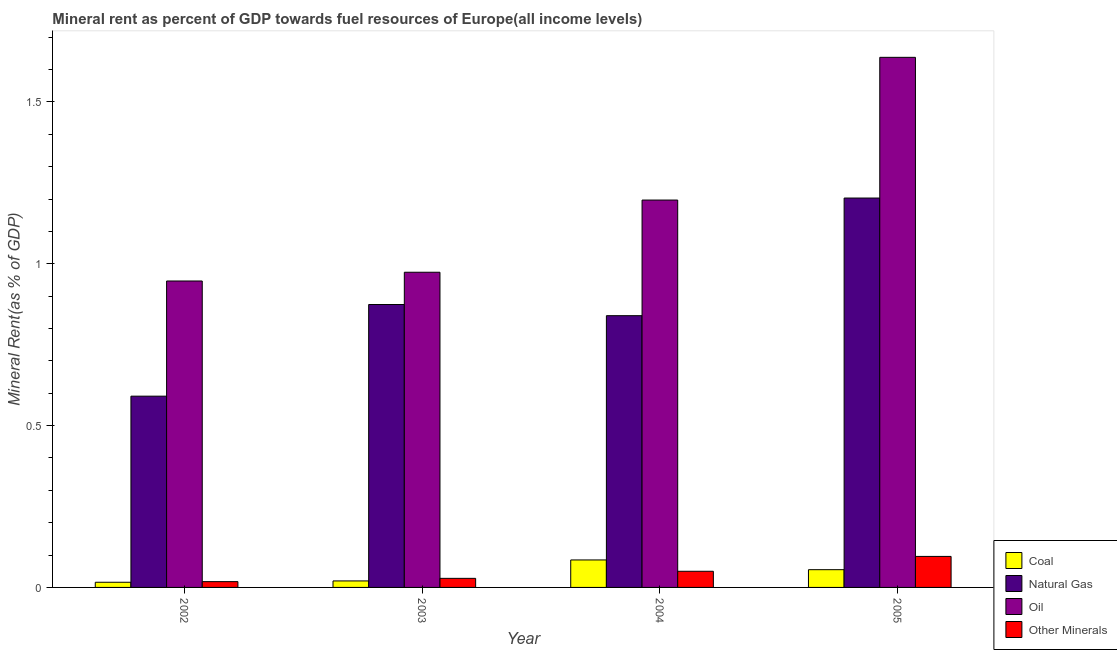How many different coloured bars are there?
Keep it short and to the point. 4. What is the label of the 2nd group of bars from the left?
Make the answer very short. 2003. In how many cases, is the number of bars for a given year not equal to the number of legend labels?
Provide a succinct answer. 0. What is the coal rent in 2003?
Your response must be concise. 0.02. Across all years, what is the maximum oil rent?
Keep it short and to the point. 1.64. Across all years, what is the minimum oil rent?
Provide a short and direct response. 0.95. What is the total coal rent in the graph?
Your answer should be compact. 0.18. What is the difference between the coal rent in 2003 and that in 2005?
Provide a short and direct response. -0.03. What is the difference between the oil rent in 2003 and the coal rent in 2002?
Your answer should be very brief. 0.03. What is the average  rent of other minerals per year?
Keep it short and to the point. 0.05. In the year 2004, what is the difference between the coal rent and oil rent?
Ensure brevity in your answer.  0. What is the ratio of the natural gas rent in 2003 to that in 2005?
Offer a very short reply. 0.73. Is the coal rent in 2004 less than that in 2005?
Your answer should be compact. No. What is the difference between the highest and the second highest natural gas rent?
Give a very brief answer. 0.33. What is the difference between the highest and the lowest oil rent?
Provide a succinct answer. 0.69. Is the sum of the coal rent in 2003 and 2004 greater than the maximum oil rent across all years?
Your answer should be very brief. Yes. Is it the case that in every year, the sum of the  rent of other minerals and coal rent is greater than the sum of natural gas rent and oil rent?
Keep it short and to the point. No. What does the 3rd bar from the left in 2002 represents?
Provide a succinct answer. Oil. What does the 4th bar from the right in 2004 represents?
Provide a short and direct response. Coal. How many bars are there?
Offer a terse response. 16. Does the graph contain any zero values?
Ensure brevity in your answer.  No. Where does the legend appear in the graph?
Offer a terse response. Bottom right. How many legend labels are there?
Your answer should be compact. 4. How are the legend labels stacked?
Ensure brevity in your answer.  Vertical. What is the title of the graph?
Offer a very short reply. Mineral rent as percent of GDP towards fuel resources of Europe(all income levels). What is the label or title of the Y-axis?
Your answer should be compact. Mineral Rent(as % of GDP). What is the Mineral Rent(as % of GDP) in Coal in 2002?
Your answer should be very brief. 0.02. What is the Mineral Rent(as % of GDP) in Natural Gas in 2002?
Make the answer very short. 0.59. What is the Mineral Rent(as % of GDP) in Oil in 2002?
Give a very brief answer. 0.95. What is the Mineral Rent(as % of GDP) in Other Minerals in 2002?
Ensure brevity in your answer.  0.02. What is the Mineral Rent(as % of GDP) of Coal in 2003?
Your response must be concise. 0.02. What is the Mineral Rent(as % of GDP) in Natural Gas in 2003?
Keep it short and to the point. 0.87. What is the Mineral Rent(as % of GDP) in Oil in 2003?
Offer a terse response. 0.97. What is the Mineral Rent(as % of GDP) of Other Minerals in 2003?
Your answer should be very brief. 0.03. What is the Mineral Rent(as % of GDP) in Coal in 2004?
Ensure brevity in your answer.  0.08. What is the Mineral Rent(as % of GDP) of Natural Gas in 2004?
Provide a succinct answer. 0.84. What is the Mineral Rent(as % of GDP) in Oil in 2004?
Ensure brevity in your answer.  1.2. What is the Mineral Rent(as % of GDP) of Other Minerals in 2004?
Offer a terse response. 0.05. What is the Mineral Rent(as % of GDP) of Coal in 2005?
Ensure brevity in your answer.  0.05. What is the Mineral Rent(as % of GDP) of Natural Gas in 2005?
Give a very brief answer. 1.2. What is the Mineral Rent(as % of GDP) of Oil in 2005?
Your answer should be compact. 1.64. What is the Mineral Rent(as % of GDP) of Other Minerals in 2005?
Your answer should be very brief. 0.1. Across all years, what is the maximum Mineral Rent(as % of GDP) of Coal?
Make the answer very short. 0.08. Across all years, what is the maximum Mineral Rent(as % of GDP) in Natural Gas?
Provide a short and direct response. 1.2. Across all years, what is the maximum Mineral Rent(as % of GDP) of Oil?
Ensure brevity in your answer.  1.64. Across all years, what is the maximum Mineral Rent(as % of GDP) of Other Minerals?
Your response must be concise. 0.1. Across all years, what is the minimum Mineral Rent(as % of GDP) of Coal?
Ensure brevity in your answer.  0.02. Across all years, what is the minimum Mineral Rent(as % of GDP) in Natural Gas?
Ensure brevity in your answer.  0.59. Across all years, what is the minimum Mineral Rent(as % of GDP) in Oil?
Your answer should be compact. 0.95. Across all years, what is the minimum Mineral Rent(as % of GDP) of Other Minerals?
Make the answer very short. 0.02. What is the total Mineral Rent(as % of GDP) in Coal in the graph?
Your response must be concise. 0.18. What is the total Mineral Rent(as % of GDP) in Natural Gas in the graph?
Provide a short and direct response. 3.51. What is the total Mineral Rent(as % of GDP) of Oil in the graph?
Offer a terse response. 4.76. What is the total Mineral Rent(as % of GDP) of Other Minerals in the graph?
Give a very brief answer. 0.19. What is the difference between the Mineral Rent(as % of GDP) of Coal in 2002 and that in 2003?
Give a very brief answer. -0. What is the difference between the Mineral Rent(as % of GDP) of Natural Gas in 2002 and that in 2003?
Your response must be concise. -0.28. What is the difference between the Mineral Rent(as % of GDP) of Oil in 2002 and that in 2003?
Ensure brevity in your answer.  -0.03. What is the difference between the Mineral Rent(as % of GDP) in Other Minerals in 2002 and that in 2003?
Make the answer very short. -0.01. What is the difference between the Mineral Rent(as % of GDP) in Coal in 2002 and that in 2004?
Offer a terse response. -0.07. What is the difference between the Mineral Rent(as % of GDP) of Natural Gas in 2002 and that in 2004?
Offer a terse response. -0.25. What is the difference between the Mineral Rent(as % of GDP) in Oil in 2002 and that in 2004?
Offer a very short reply. -0.25. What is the difference between the Mineral Rent(as % of GDP) in Other Minerals in 2002 and that in 2004?
Offer a very short reply. -0.03. What is the difference between the Mineral Rent(as % of GDP) of Coal in 2002 and that in 2005?
Your answer should be very brief. -0.04. What is the difference between the Mineral Rent(as % of GDP) in Natural Gas in 2002 and that in 2005?
Provide a short and direct response. -0.61. What is the difference between the Mineral Rent(as % of GDP) of Oil in 2002 and that in 2005?
Keep it short and to the point. -0.69. What is the difference between the Mineral Rent(as % of GDP) of Other Minerals in 2002 and that in 2005?
Make the answer very short. -0.08. What is the difference between the Mineral Rent(as % of GDP) of Coal in 2003 and that in 2004?
Keep it short and to the point. -0.06. What is the difference between the Mineral Rent(as % of GDP) in Natural Gas in 2003 and that in 2004?
Offer a terse response. 0.03. What is the difference between the Mineral Rent(as % of GDP) in Oil in 2003 and that in 2004?
Your answer should be compact. -0.22. What is the difference between the Mineral Rent(as % of GDP) of Other Minerals in 2003 and that in 2004?
Ensure brevity in your answer.  -0.02. What is the difference between the Mineral Rent(as % of GDP) in Coal in 2003 and that in 2005?
Offer a terse response. -0.03. What is the difference between the Mineral Rent(as % of GDP) of Natural Gas in 2003 and that in 2005?
Your response must be concise. -0.33. What is the difference between the Mineral Rent(as % of GDP) in Oil in 2003 and that in 2005?
Keep it short and to the point. -0.66. What is the difference between the Mineral Rent(as % of GDP) in Other Minerals in 2003 and that in 2005?
Offer a terse response. -0.07. What is the difference between the Mineral Rent(as % of GDP) of Coal in 2004 and that in 2005?
Keep it short and to the point. 0.03. What is the difference between the Mineral Rent(as % of GDP) in Natural Gas in 2004 and that in 2005?
Make the answer very short. -0.36. What is the difference between the Mineral Rent(as % of GDP) in Oil in 2004 and that in 2005?
Offer a terse response. -0.44. What is the difference between the Mineral Rent(as % of GDP) of Other Minerals in 2004 and that in 2005?
Provide a short and direct response. -0.05. What is the difference between the Mineral Rent(as % of GDP) of Coal in 2002 and the Mineral Rent(as % of GDP) of Natural Gas in 2003?
Give a very brief answer. -0.86. What is the difference between the Mineral Rent(as % of GDP) in Coal in 2002 and the Mineral Rent(as % of GDP) in Oil in 2003?
Ensure brevity in your answer.  -0.96. What is the difference between the Mineral Rent(as % of GDP) in Coal in 2002 and the Mineral Rent(as % of GDP) in Other Minerals in 2003?
Provide a succinct answer. -0.01. What is the difference between the Mineral Rent(as % of GDP) in Natural Gas in 2002 and the Mineral Rent(as % of GDP) in Oil in 2003?
Your answer should be very brief. -0.38. What is the difference between the Mineral Rent(as % of GDP) of Natural Gas in 2002 and the Mineral Rent(as % of GDP) of Other Minerals in 2003?
Make the answer very short. 0.56. What is the difference between the Mineral Rent(as % of GDP) in Oil in 2002 and the Mineral Rent(as % of GDP) in Other Minerals in 2003?
Your answer should be compact. 0.92. What is the difference between the Mineral Rent(as % of GDP) in Coal in 2002 and the Mineral Rent(as % of GDP) in Natural Gas in 2004?
Provide a short and direct response. -0.82. What is the difference between the Mineral Rent(as % of GDP) in Coal in 2002 and the Mineral Rent(as % of GDP) in Oil in 2004?
Make the answer very short. -1.18. What is the difference between the Mineral Rent(as % of GDP) in Coal in 2002 and the Mineral Rent(as % of GDP) in Other Minerals in 2004?
Provide a succinct answer. -0.03. What is the difference between the Mineral Rent(as % of GDP) in Natural Gas in 2002 and the Mineral Rent(as % of GDP) in Oil in 2004?
Your answer should be compact. -0.61. What is the difference between the Mineral Rent(as % of GDP) of Natural Gas in 2002 and the Mineral Rent(as % of GDP) of Other Minerals in 2004?
Provide a short and direct response. 0.54. What is the difference between the Mineral Rent(as % of GDP) of Oil in 2002 and the Mineral Rent(as % of GDP) of Other Minerals in 2004?
Ensure brevity in your answer.  0.9. What is the difference between the Mineral Rent(as % of GDP) of Coal in 2002 and the Mineral Rent(as % of GDP) of Natural Gas in 2005?
Keep it short and to the point. -1.19. What is the difference between the Mineral Rent(as % of GDP) in Coal in 2002 and the Mineral Rent(as % of GDP) in Oil in 2005?
Offer a very short reply. -1.62. What is the difference between the Mineral Rent(as % of GDP) of Coal in 2002 and the Mineral Rent(as % of GDP) of Other Minerals in 2005?
Offer a terse response. -0.08. What is the difference between the Mineral Rent(as % of GDP) of Natural Gas in 2002 and the Mineral Rent(as % of GDP) of Oil in 2005?
Give a very brief answer. -1.05. What is the difference between the Mineral Rent(as % of GDP) in Natural Gas in 2002 and the Mineral Rent(as % of GDP) in Other Minerals in 2005?
Provide a succinct answer. 0.5. What is the difference between the Mineral Rent(as % of GDP) of Oil in 2002 and the Mineral Rent(as % of GDP) of Other Minerals in 2005?
Your answer should be compact. 0.85. What is the difference between the Mineral Rent(as % of GDP) in Coal in 2003 and the Mineral Rent(as % of GDP) in Natural Gas in 2004?
Make the answer very short. -0.82. What is the difference between the Mineral Rent(as % of GDP) in Coal in 2003 and the Mineral Rent(as % of GDP) in Oil in 2004?
Keep it short and to the point. -1.18. What is the difference between the Mineral Rent(as % of GDP) in Coal in 2003 and the Mineral Rent(as % of GDP) in Other Minerals in 2004?
Ensure brevity in your answer.  -0.03. What is the difference between the Mineral Rent(as % of GDP) of Natural Gas in 2003 and the Mineral Rent(as % of GDP) of Oil in 2004?
Ensure brevity in your answer.  -0.32. What is the difference between the Mineral Rent(as % of GDP) in Natural Gas in 2003 and the Mineral Rent(as % of GDP) in Other Minerals in 2004?
Provide a short and direct response. 0.82. What is the difference between the Mineral Rent(as % of GDP) of Oil in 2003 and the Mineral Rent(as % of GDP) of Other Minerals in 2004?
Your response must be concise. 0.92. What is the difference between the Mineral Rent(as % of GDP) of Coal in 2003 and the Mineral Rent(as % of GDP) of Natural Gas in 2005?
Keep it short and to the point. -1.18. What is the difference between the Mineral Rent(as % of GDP) in Coal in 2003 and the Mineral Rent(as % of GDP) in Oil in 2005?
Your answer should be compact. -1.62. What is the difference between the Mineral Rent(as % of GDP) in Coal in 2003 and the Mineral Rent(as % of GDP) in Other Minerals in 2005?
Your answer should be very brief. -0.08. What is the difference between the Mineral Rent(as % of GDP) in Natural Gas in 2003 and the Mineral Rent(as % of GDP) in Oil in 2005?
Your response must be concise. -0.76. What is the difference between the Mineral Rent(as % of GDP) of Natural Gas in 2003 and the Mineral Rent(as % of GDP) of Other Minerals in 2005?
Offer a very short reply. 0.78. What is the difference between the Mineral Rent(as % of GDP) of Oil in 2003 and the Mineral Rent(as % of GDP) of Other Minerals in 2005?
Give a very brief answer. 0.88. What is the difference between the Mineral Rent(as % of GDP) in Coal in 2004 and the Mineral Rent(as % of GDP) in Natural Gas in 2005?
Ensure brevity in your answer.  -1.12. What is the difference between the Mineral Rent(as % of GDP) in Coal in 2004 and the Mineral Rent(as % of GDP) in Oil in 2005?
Offer a very short reply. -1.55. What is the difference between the Mineral Rent(as % of GDP) in Coal in 2004 and the Mineral Rent(as % of GDP) in Other Minerals in 2005?
Offer a very short reply. -0.01. What is the difference between the Mineral Rent(as % of GDP) in Natural Gas in 2004 and the Mineral Rent(as % of GDP) in Oil in 2005?
Offer a very short reply. -0.8. What is the difference between the Mineral Rent(as % of GDP) of Natural Gas in 2004 and the Mineral Rent(as % of GDP) of Other Minerals in 2005?
Offer a terse response. 0.74. What is the difference between the Mineral Rent(as % of GDP) in Oil in 2004 and the Mineral Rent(as % of GDP) in Other Minerals in 2005?
Your answer should be very brief. 1.1. What is the average Mineral Rent(as % of GDP) in Coal per year?
Ensure brevity in your answer.  0.04. What is the average Mineral Rent(as % of GDP) of Natural Gas per year?
Give a very brief answer. 0.88. What is the average Mineral Rent(as % of GDP) in Oil per year?
Your answer should be very brief. 1.19. What is the average Mineral Rent(as % of GDP) in Other Minerals per year?
Offer a terse response. 0.05. In the year 2002, what is the difference between the Mineral Rent(as % of GDP) in Coal and Mineral Rent(as % of GDP) in Natural Gas?
Your response must be concise. -0.57. In the year 2002, what is the difference between the Mineral Rent(as % of GDP) of Coal and Mineral Rent(as % of GDP) of Oil?
Offer a terse response. -0.93. In the year 2002, what is the difference between the Mineral Rent(as % of GDP) in Coal and Mineral Rent(as % of GDP) in Other Minerals?
Your answer should be very brief. -0. In the year 2002, what is the difference between the Mineral Rent(as % of GDP) in Natural Gas and Mineral Rent(as % of GDP) in Oil?
Your answer should be very brief. -0.36. In the year 2002, what is the difference between the Mineral Rent(as % of GDP) of Natural Gas and Mineral Rent(as % of GDP) of Other Minerals?
Your response must be concise. 0.57. In the year 2002, what is the difference between the Mineral Rent(as % of GDP) of Oil and Mineral Rent(as % of GDP) of Other Minerals?
Offer a terse response. 0.93. In the year 2003, what is the difference between the Mineral Rent(as % of GDP) in Coal and Mineral Rent(as % of GDP) in Natural Gas?
Make the answer very short. -0.85. In the year 2003, what is the difference between the Mineral Rent(as % of GDP) of Coal and Mineral Rent(as % of GDP) of Oil?
Give a very brief answer. -0.95. In the year 2003, what is the difference between the Mineral Rent(as % of GDP) of Coal and Mineral Rent(as % of GDP) of Other Minerals?
Keep it short and to the point. -0.01. In the year 2003, what is the difference between the Mineral Rent(as % of GDP) in Natural Gas and Mineral Rent(as % of GDP) in Oil?
Keep it short and to the point. -0.1. In the year 2003, what is the difference between the Mineral Rent(as % of GDP) of Natural Gas and Mineral Rent(as % of GDP) of Other Minerals?
Your answer should be very brief. 0.85. In the year 2003, what is the difference between the Mineral Rent(as % of GDP) of Oil and Mineral Rent(as % of GDP) of Other Minerals?
Make the answer very short. 0.95. In the year 2004, what is the difference between the Mineral Rent(as % of GDP) in Coal and Mineral Rent(as % of GDP) in Natural Gas?
Offer a terse response. -0.75. In the year 2004, what is the difference between the Mineral Rent(as % of GDP) of Coal and Mineral Rent(as % of GDP) of Oil?
Your response must be concise. -1.11. In the year 2004, what is the difference between the Mineral Rent(as % of GDP) in Coal and Mineral Rent(as % of GDP) in Other Minerals?
Your answer should be compact. 0.04. In the year 2004, what is the difference between the Mineral Rent(as % of GDP) of Natural Gas and Mineral Rent(as % of GDP) of Oil?
Provide a short and direct response. -0.36. In the year 2004, what is the difference between the Mineral Rent(as % of GDP) of Natural Gas and Mineral Rent(as % of GDP) of Other Minerals?
Your response must be concise. 0.79. In the year 2004, what is the difference between the Mineral Rent(as % of GDP) of Oil and Mineral Rent(as % of GDP) of Other Minerals?
Provide a succinct answer. 1.15. In the year 2005, what is the difference between the Mineral Rent(as % of GDP) of Coal and Mineral Rent(as % of GDP) of Natural Gas?
Make the answer very short. -1.15. In the year 2005, what is the difference between the Mineral Rent(as % of GDP) of Coal and Mineral Rent(as % of GDP) of Oil?
Keep it short and to the point. -1.58. In the year 2005, what is the difference between the Mineral Rent(as % of GDP) in Coal and Mineral Rent(as % of GDP) in Other Minerals?
Offer a very short reply. -0.04. In the year 2005, what is the difference between the Mineral Rent(as % of GDP) in Natural Gas and Mineral Rent(as % of GDP) in Oil?
Ensure brevity in your answer.  -0.43. In the year 2005, what is the difference between the Mineral Rent(as % of GDP) in Natural Gas and Mineral Rent(as % of GDP) in Other Minerals?
Offer a terse response. 1.11. In the year 2005, what is the difference between the Mineral Rent(as % of GDP) of Oil and Mineral Rent(as % of GDP) of Other Minerals?
Your response must be concise. 1.54. What is the ratio of the Mineral Rent(as % of GDP) in Coal in 2002 to that in 2003?
Offer a very short reply. 0.8. What is the ratio of the Mineral Rent(as % of GDP) of Natural Gas in 2002 to that in 2003?
Ensure brevity in your answer.  0.68. What is the ratio of the Mineral Rent(as % of GDP) of Oil in 2002 to that in 2003?
Offer a terse response. 0.97. What is the ratio of the Mineral Rent(as % of GDP) in Other Minerals in 2002 to that in 2003?
Your response must be concise. 0.64. What is the ratio of the Mineral Rent(as % of GDP) in Coal in 2002 to that in 2004?
Your answer should be compact. 0.19. What is the ratio of the Mineral Rent(as % of GDP) of Natural Gas in 2002 to that in 2004?
Your answer should be very brief. 0.7. What is the ratio of the Mineral Rent(as % of GDP) in Oil in 2002 to that in 2004?
Your response must be concise. 0.79. What is the ratio of the Mineral Rent(as % of GDP) of Other Minerals in 2002 to that in 2004?
Offer a very short reply. 0.36. What is the ratio of the Mineral Rent(as % of GDP) of Coal in 2002 to that in 2005?
Your response must be concise. 0.29. What is the ratio of the Mineral Rent(as % of GDP) in Natural Gas in 2002 to that in 2005?
Offer a terse response. 0.49. What is the ratio of the Mineral Rent(as % of GDP) of Oil in 2002 to that in 2005?
Provide a succinct answer. 0.58. What is the ratio of the Mineral Rent(as % of GDP) in Other Minerals in 2002 to that in 2005?
Ensure brevity in your answer.  0.19. What is the ratio of the Mineral Rent(as % of GDP) in Coal in 2003 to that in 2004?
Your answer should be very brief. 0.24. What is the ratio of the Mineral Rent(as % of GDP) in Natural Gas in 2003 to that in 2004?
Offer a terse response. 1.04. What is the ratio of the Mineral Rent(as % of GDP) of Oil in 2003 to that in 2004?
Your answer should be compact. 0.81. What is the ratio of the Mineral Rent(as % of GDP) in Other Minerals in 2003 to that in 2004?
Your response must be concise. 0.56. What is the ratio of the Mineral Rent(as % of GDP) in Coal in 2003 to that in 2005?
Keep it short and to the point. 0.37. What is the ratio of the Mineral Rent(as % of GDP) of Natural Gas in 2003 to that in 2005?
Offer a terse response. 0.73. What is the ratio of the Mineral Rent(as % of GDP) of Oil in 2003 to that in 2005?
Provide a short and direct response. 0.59. What is the ratio of the Mineral Rent(as % of GDP) of Other Minerals in 2003 to that in 2005?
Give a very brief answer. 0.29. What is the ratio of the Mineral Rent(as % of GDP) in Coal in 2004 to that in 2005?
Provide a succinct answer. 1.55. What is the ratio of the Mineral Rent(as % of GDP) in Natural Gas in 2004 to that in 2005?
Ensure brevity in your answer.  0.7. What is the ratio of the Mineral Rent(as % of GDP) in Oil in 2004 to that in 2005?
Provide a short and direct response. 0.73. What is the ratio of the Mineral Rent(as % of GDP) in Other Minerals in 2004 to that in 2005?
Ensure brevity in your answer.  0.52. What is the difference between the highest and the second highest Mineral Rent(as % of GDP) in Coal?
Make the answer very short. 0.03. What is the difference between the highest and the second highest Mineral Rent(as % of GDP) of Natural Gas?
Keep it short and to the point. 0.33. What is the difference between the highest and the second highest Mineral Rent(as % of GDP) of Oil?
Provide a succinct answer. 0.44. What is the difference between the highest and the second highest Mineral Rent(as % of GDP) in Other Minerals?
Give a very brief answer. 0.05. What is the difference between the highest and the lowest Mineral Rent(as % of GDP) in Coal?
Make the answer very short. 0.07. What is the difference between the highest and the lowest Mineral Rent(as % of GDP) of Natural Gas?
Provide a succinct answer. 0.61. What is the difference between the highest and the lowest Mineral Rent(as % of GDP) of Oil?
Make the answer very short. 0.69. What is the difference between the highest and the lowest Mineral Rent(as % of GDP) of Other Minerals?
Keep it short and to the point. 0.08. 